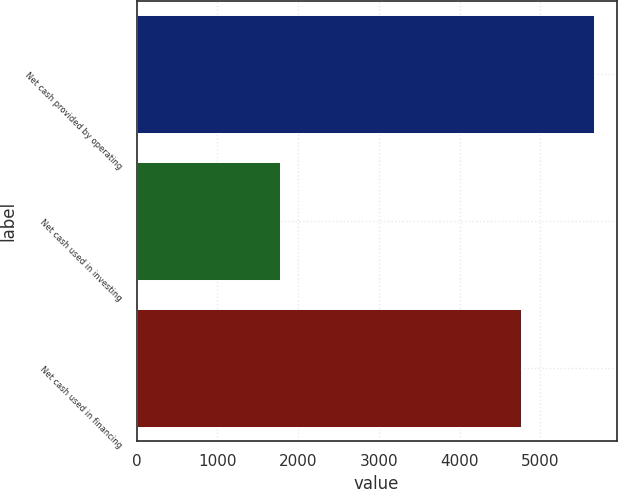Convert chart to OTSL. <chart><loc_0><loc_0><loc_500><loc_500><bar_chart><fcel>Net cash provided by operating<fcel>Net cash used in investing<fcel>Net cash used in financing<nl><fcel>5664<fcel>1781<fcel>4764<nl></chart> 